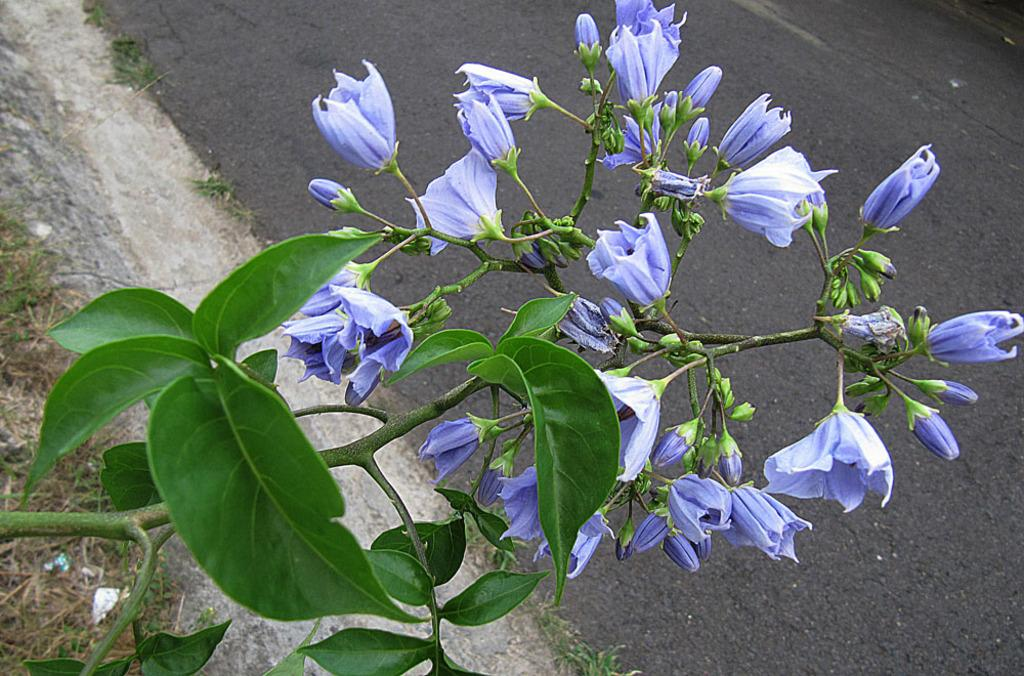What is the main subject of the image? There is a group of flowers in the image. Can you describe the flowers in more detail? Yes, there are buds in the image. What can be seen in the background of the image? There is a road visible behind the flowers. How does the baby cause trouble for the flowers in the image? There is no baby present in the image, so it cannot cause any trouble for the flowers. 